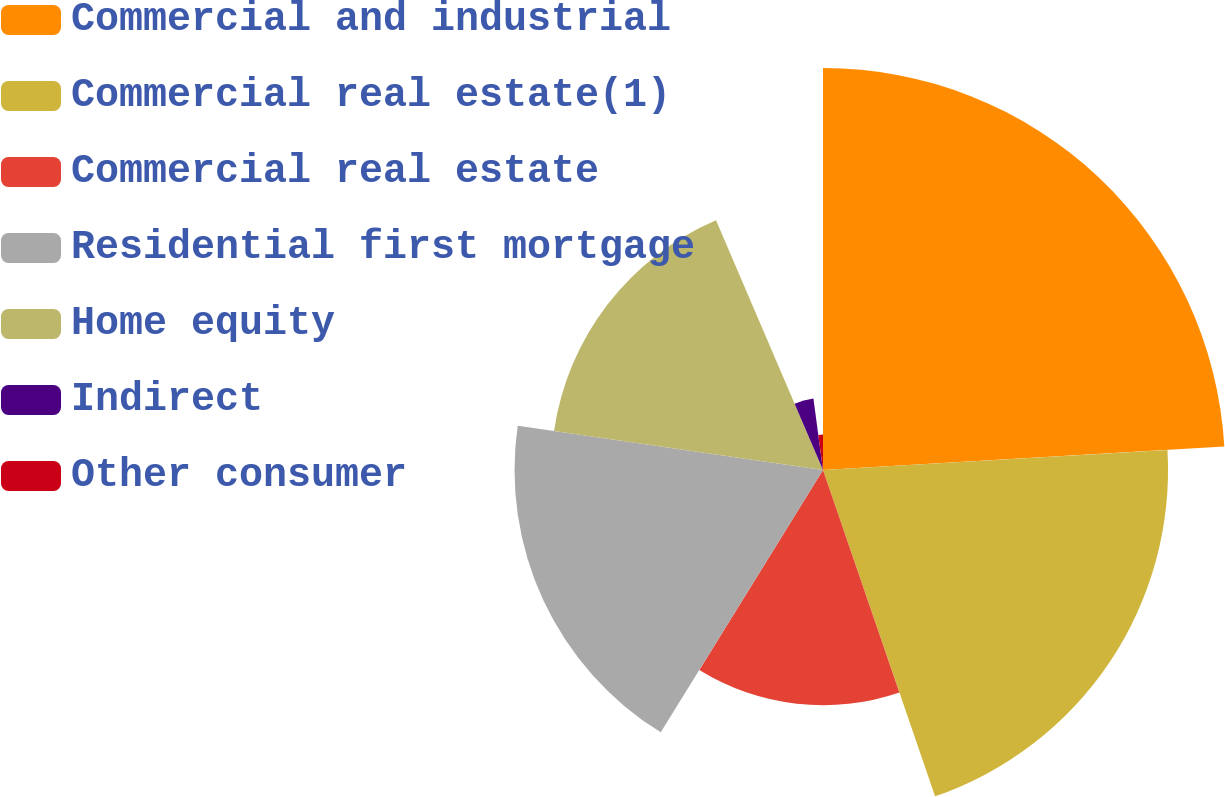Convert chart. <chart><loc_0><loc_0><loc_500><loc_500><pie_chart><fcel>Commercial and industrial<fcel>Commercial real estate(1)<fcel>Commercial real estate<fcel>Residential first mortgage<fcel>Home equity<fcel>Indirect<fcel>Other consumer<nl><fcel>24.07%<fcel>20.66%<fcel>14.08%<fcel>18.47%<fcel>16.27%<fcel>4.32%<fcel>2.12%<nl></chart> 